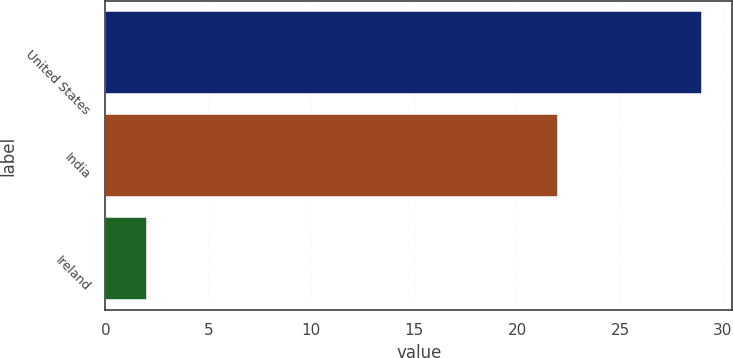<chart> <loc_0><loc_0><loc_500><loc_500><bar_chart><fcel>United States<fcel>India<fcel>Ireland<nl><fcel>29<fcel>22<fcel>2<nl></chart> 